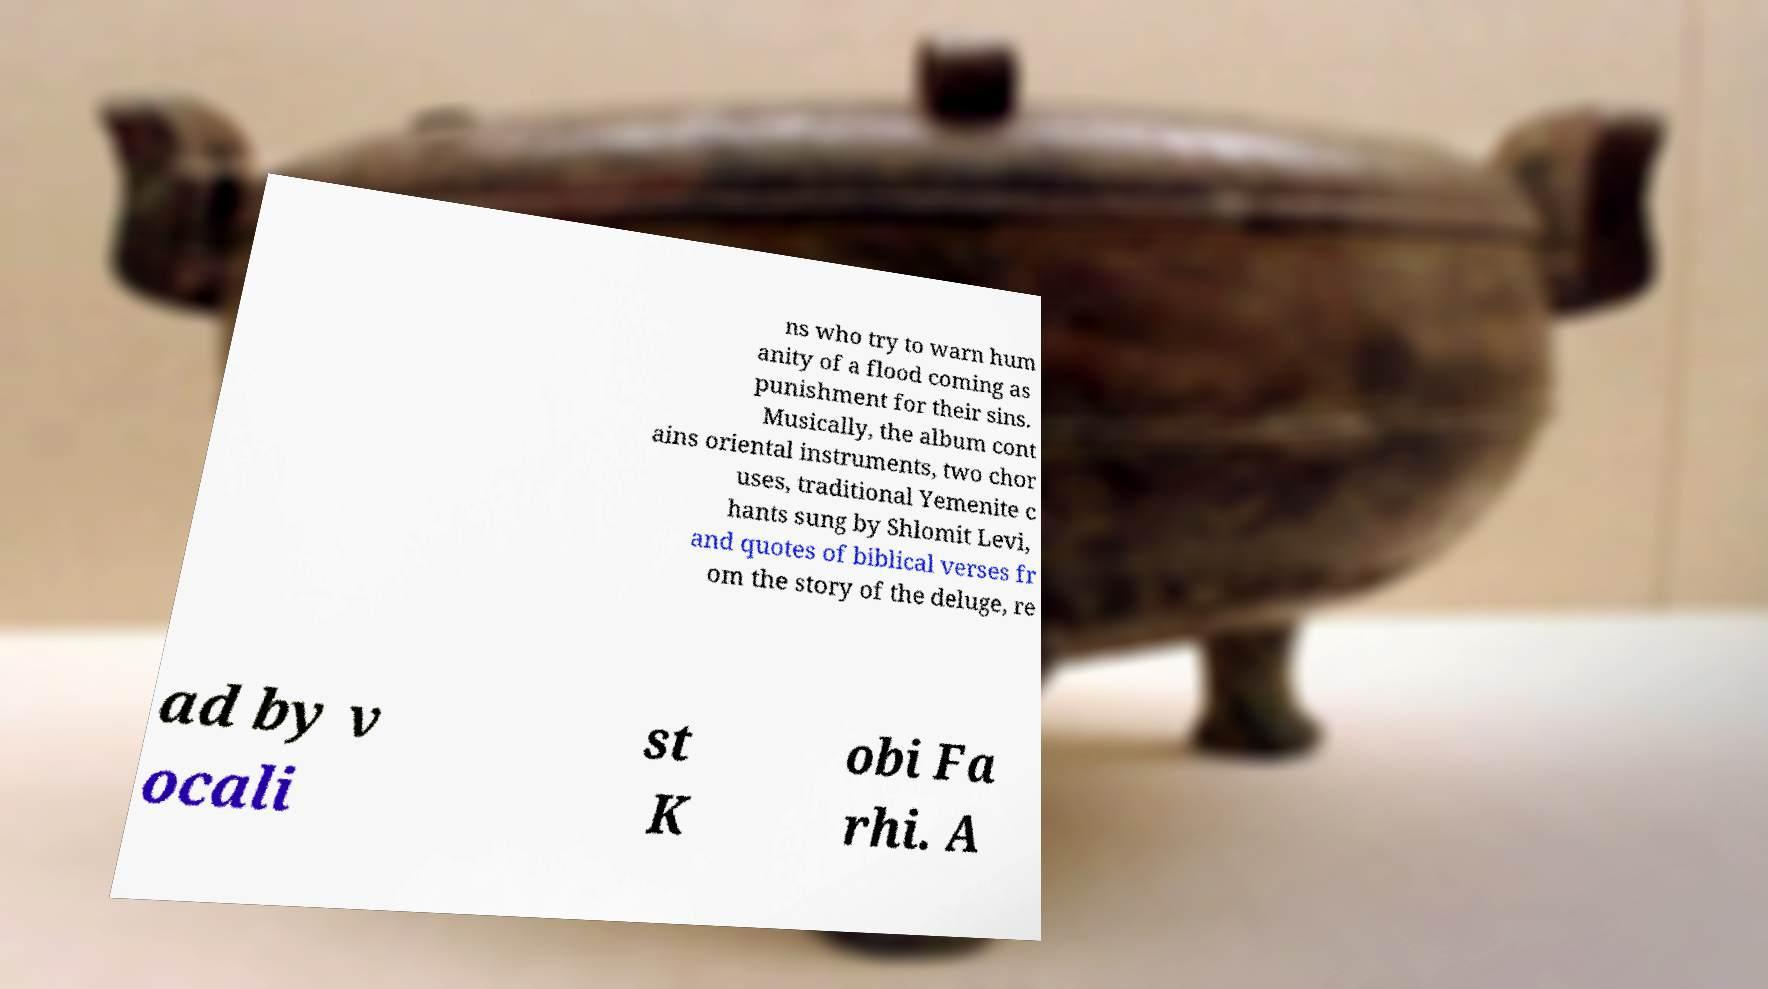Can you accurately transcribe the text from the provided image for me? ns who try to warn hum anity of a flood coming as punishment for their sins. Musically, the album cont ains oriental instruments, two chor uses, traditional Yemenite c hants sung by Shlomit Levi, and quotes of biblical verses fr om the story of the deluge, re ad by v ocali st K obi Fa rhi. A 